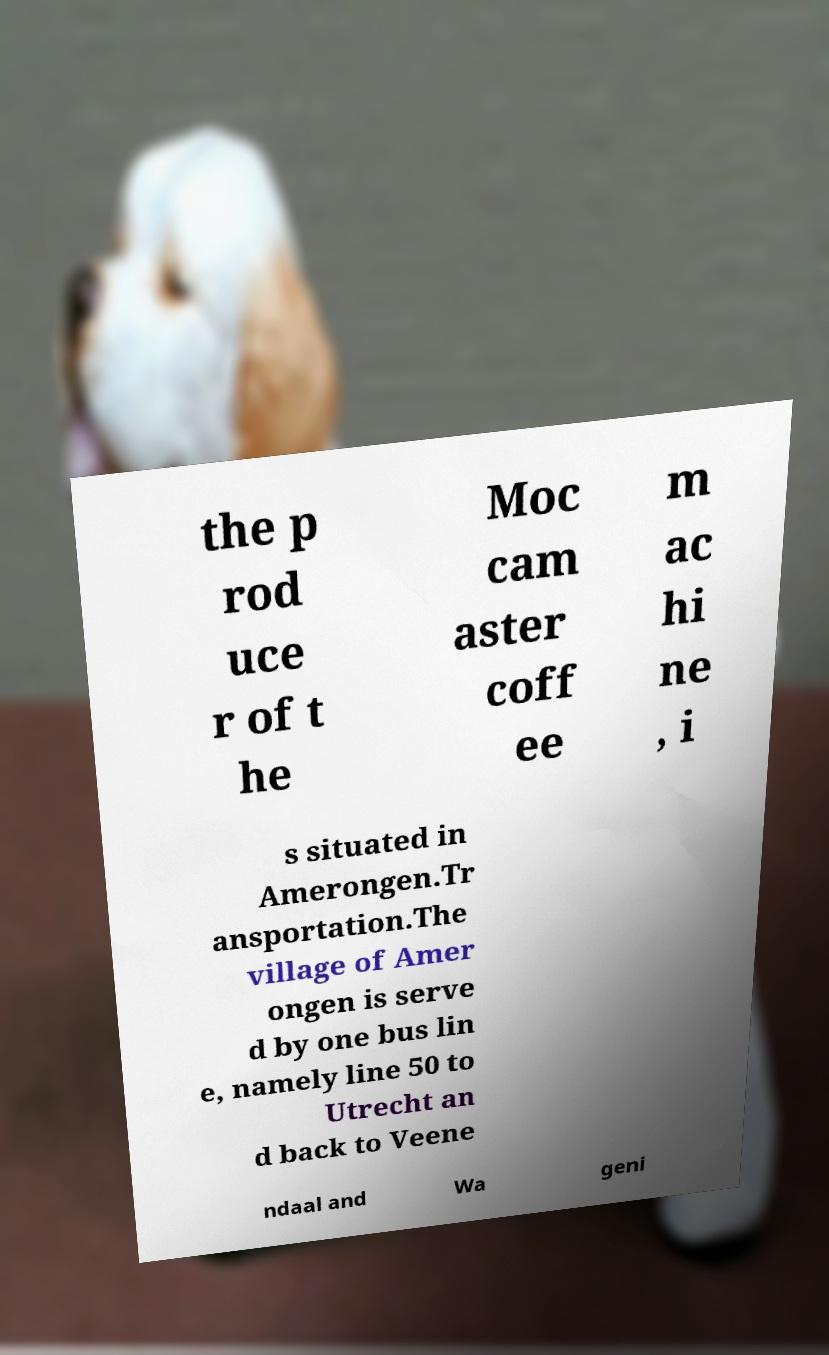I need the written content from this picture converted into text. Can you do that? the p rod uce r of t he Moc cam aster coff ee m ac hi ne , i s situated in Amerongen.Tr ansportation.The village of Amer ongen is serve d by one bus lin e, namely line 50 to Utrecht an d back to Veene ndaal and Wa geni 